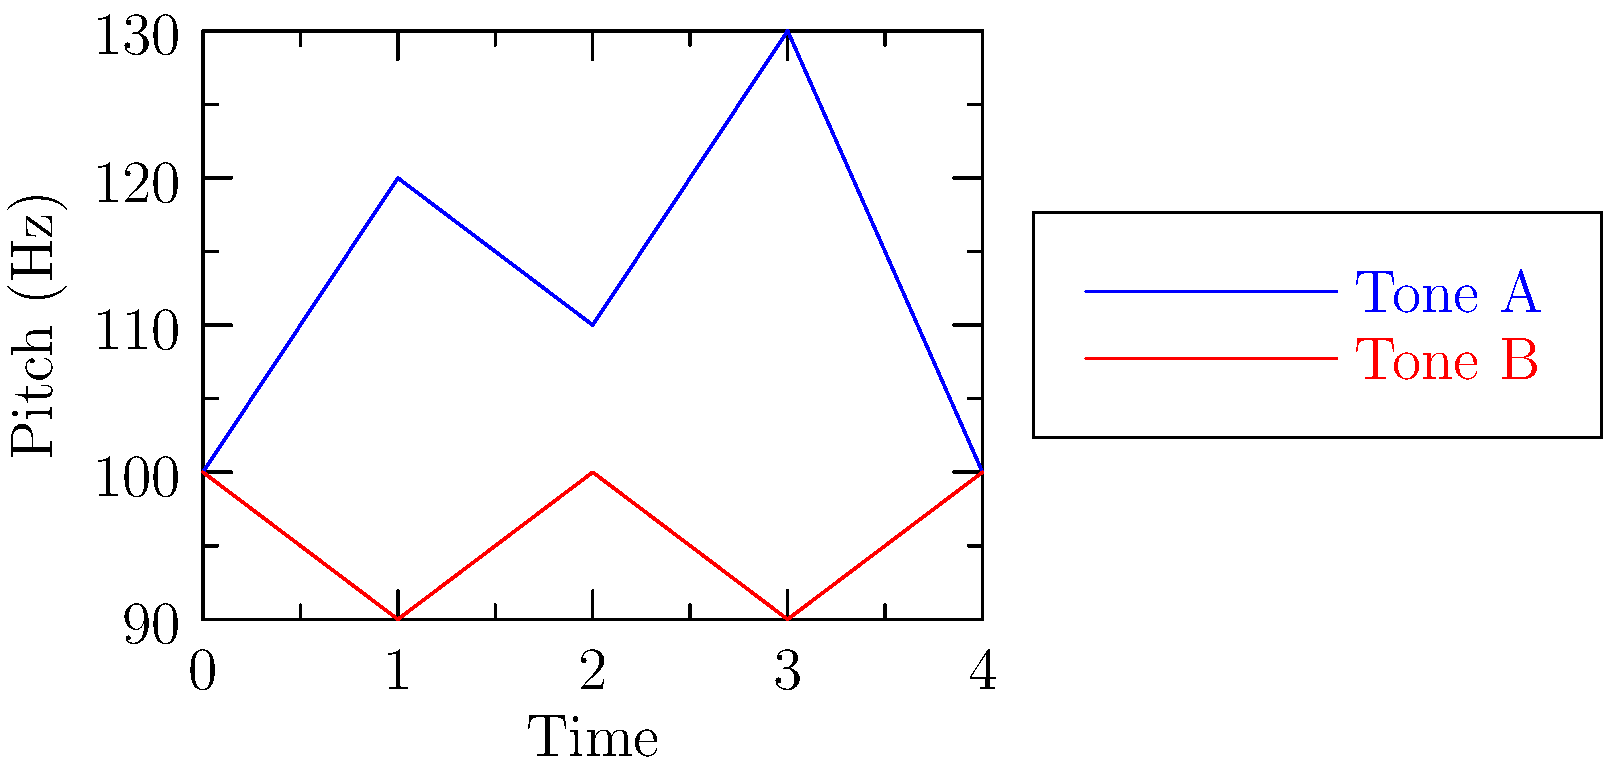Based on the pitch contours shown in the graph, which of the following statements is true about Korean tones A and B?

a) Tone A has a consistently higher pitch than Tone B
b) Tone B shows more pitch variation than Tone A
c) Tone A exhibits a rising-falling-rising pattern
d) Tone B maintains a relatively stable pitch throughout To answer this question, let's analyze the pitch contours of Tone A and Tone B step by step:

1. Tone A (blue line):
   - Starts at 100 Hz
   - Rises to 120 Hz
   - Falls to 110 Hz
   - Rises again to 130 Hz
   - Finally drops back to 100 Hz

2. Tone B (red line):
   - Starts at 100 Hz
   - Falls slightly to 90 Hz
   - Returns to 100 Hz
   - Falls again to 90 Hz
   - Ends at 100 Hz

3. Comparing the two tones:
   a) Tone A is not consistently higher than Tone B. It starts and ends at the same pitch as Tone B.
   b) Tone A shows more pitch variation (range: 100-130 Hz) compared to Tone B (range: 90-100 Hz).
   c) Tone A indeed exhibits a rising-falling-rising pattern (100 → 120 → 110 → 130 → 100 Hz).
   d) Tone B maintains a relatively stable pitch, fluctuating only slightly between 90 and 100 Hz.

Based on this analysis, the correct statement is option c: Tone A exhibits a rising-falling-rising pattern.
Answer: c) Tone A exhibits a rising-falling-rising pattern 